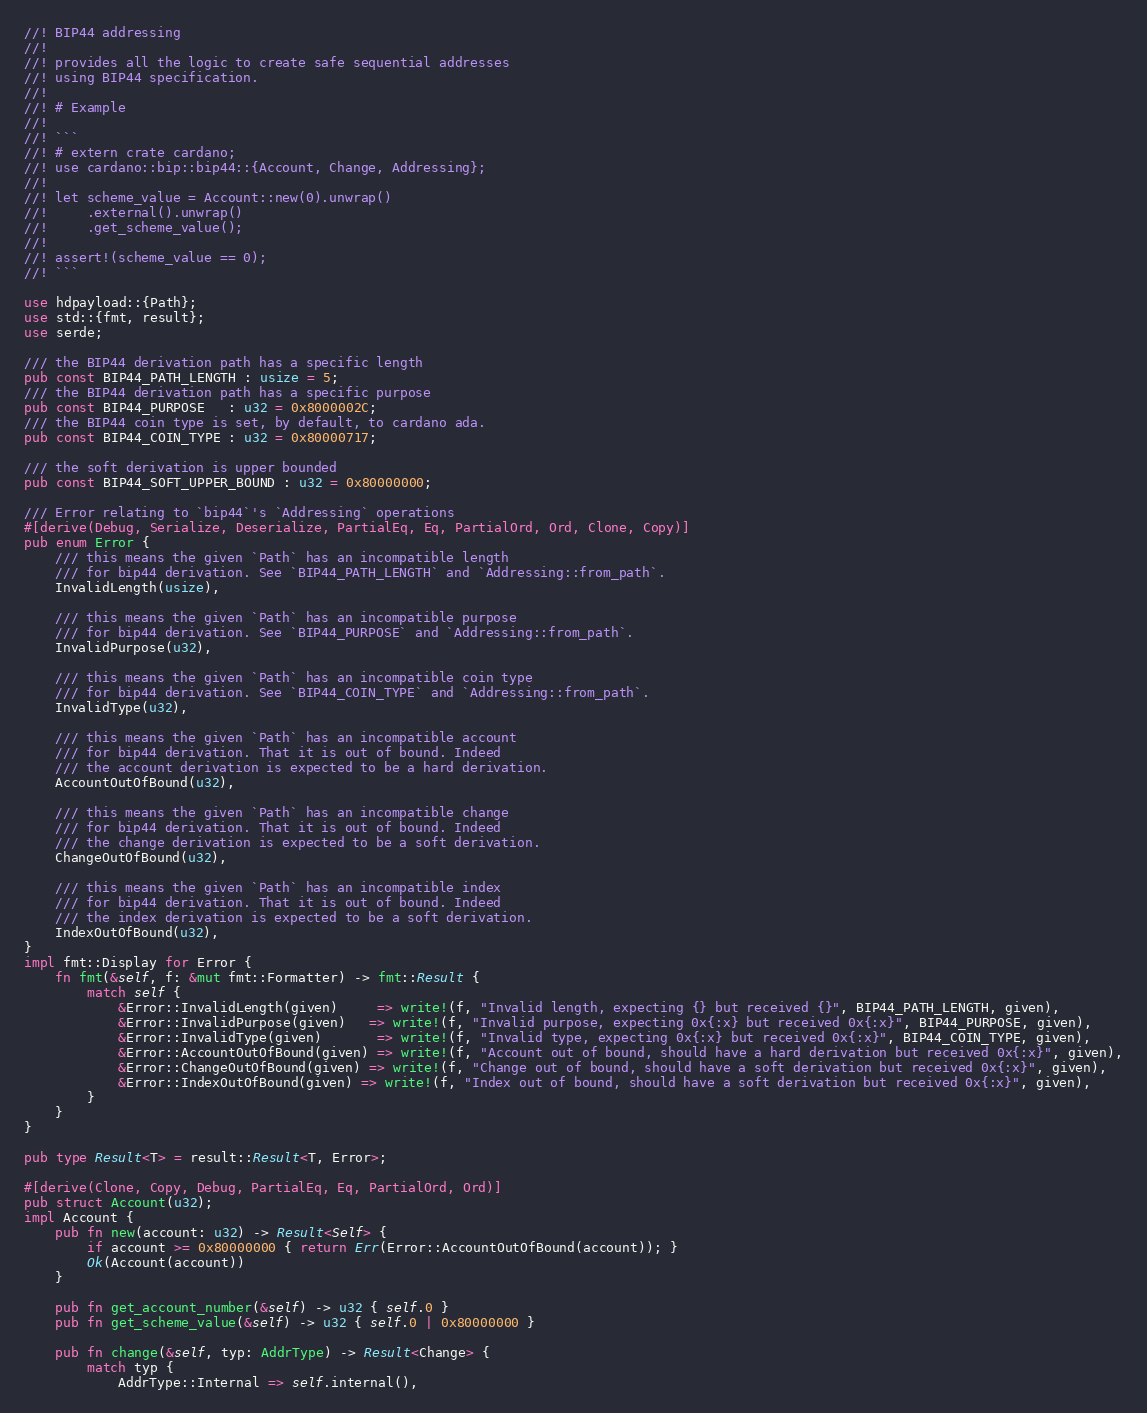<code> <loc_0><loc_0><loc_500><loc_500><_Rust_>//! BIP44 addressing
//!
//! provides all the logic to create safe sequential addresses
//! using BIP44 specification.
//!
//! # Example
//!
//! ```
//! # extern crate cardano;
//! use cardano::bip::bip44::{Account, Change, Addressing};
//!
//! let scheme_value = Account::new(0).unwrap()
//!     .external().unwrap()
//!     .get_scheme_value();
//!
//! assert!(scheme_value == 0);
//! ```

use hdpayload::{Path};
use std::{fmt, result};
use serde;

/// the BIP44 derivation path has a specific length
pub const BIP44_PATH_LENGTH : usize = 5;
/// the BIP44 derivation path has a specific purpose
pub const BIP44_PURPOSE   : u32 = 0x8000002C;
/// the BIP44 coin type is set, by default, to cardano ada.
pub const BIP44_COIN_TYPE : u32 = 0x80000717;

/// the soft derivation is upper bounded
pub const BIP44_SOFT_UPPER_BOUND : u32 = 0x80000000;

/// Error relating to `bip44`'s `Addressing` operations
#[derive(Debug, Serialize, Deserialize, PartialEq, Eq, PartialOrd, Ord, Clone, Copy)]
pub enum Error {
    /// this means the given `Path` has an incompatible length
    /// for bip44 derivation. See `BIP44_PATH_LENGTH` and `Addressing::from_path`.
    InvalidLength(usize),

    /// this means the given `Path` has an incompatible purpose
    /// for bip44 derivation. See `BIP44_PURPOSE` and `Addressing::from_path`.
    InvalidPurpose(u32),

    /// this means the given `Path` has an incompatible coin type
    /// for bip44 derivation. See `BIP44_COIN_TYPE` and `Addressing::from_path`.
    InvalidType(u32),

    /// this means the given `Path` has an incompatible account
    /// for bip44 derivation. That it is out of bound. Indeed
    /// the account derivation is expected to be a hard derivation.
    AccountOutOfBound(u32),

    /// this means the given `Path` has an incompatible change
    /// for bip44 derivation. That it is out of bound. Indeed
    /// the change derivation is expected to be a soft derivation.
    ChangeOutOfBound(u32),

    /// this means the given `Path` has an incompatible index
    /// for bip44 derivation. That it is out of bound. Indeed
    /// the index derivation is expected to be a soft derivation.
    IndexOutOfBound(u32),
}
impl fmt::Display for Error {
    fn fmt(&self, f: &mut fmt::Formatter) -> fmt::Result {
        match self {
            &Error::InvalidLength(given)     => write!(f, "Invalid length, expecting {} but received {}", BIP44_PATH_LENGTH, given),
            &Error::InvalidPurpose(given)   => write!(f, "Invalid purpose, expecting 0x{:x} but received 0x{:x}", BIP44_PURPOSE, given),
            &Error::InvalidType(given)       => write!(f, "Invalid type, expecting 0x{:x} but received 0x{:x}", BIP44_COIN_TYPE, given),
            &Error::AccountOutOfBound(given) => write!(f, "Account out of bound, should have a hard derivation but received 0x{:x}", given),
            &Error::ChangeOutOfBound(given) => write!(f, "Change out of bound, should have a soft derivation but received 0x{:x}", given),
            &Error::IndexOutOfBound(given) => write!(f, "Index out of bound, should have a soft derivation but received 0x{:x}", given),
        }
    }
}

pub type Result<T> = result::Result<T, Error>;

#[derive(Clone, Copy, Debug, PartialEq, Eq, PartialOrd, Ord)]
pub struct Account(u32);
impl Account {
    pub fn new(account: u32) -> Result<Self> {
        if account >= 0x80000000 { return Err(Error::AccountOutOfBound(account)); }
        Ok(Account(account))
    }

    pub fn get_account_number(&self) -> u32 { self.0 }
    pub fn get_scheme_value(&self) -> u32 { self.0 | 0x80000000 }

    pub fn change(&self, typ: AddrType) -> Result<Change> {
        match typ {
            AddrType::Internal => self.internal(),</code> 